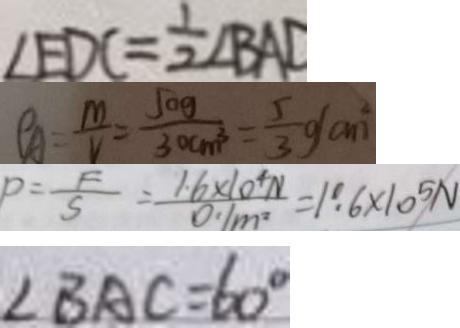<formula> <loc_0><loc_0><loc_500><loc_500>\angle E D C = \frac { 1 } { 2 } \angle B A D 
 p A = \frac { m } { V } = \frac { 5 0 g } { 3 0 c m ^ { 3 } } = \frac { 5 } { 3 } g ( a ^ { 2 } ) 
 P = \frac { F } { S } = \frac { 1 . 6 \times 1 0 ^ { 4 } N } { 0 . 1 m ^ { 2 } } = 1 . 6 \times 1 0 ^ { 5 } N 
 \angle B A C = 6 0 ^ { \circ }</formula> 